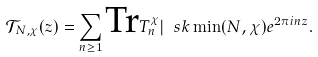Convert formula to latex. <formula><loc_0><loc_0><loc_500><loc_500>\mathcal { T } _ { N , \chi } ( z ) = \sum _ { n \geq 1 } \text {Tr} T _ { n } ^ { \chi } | \ s k \min ( N , \chi ) e ^ { 2 \pi i n z } .</formula> 